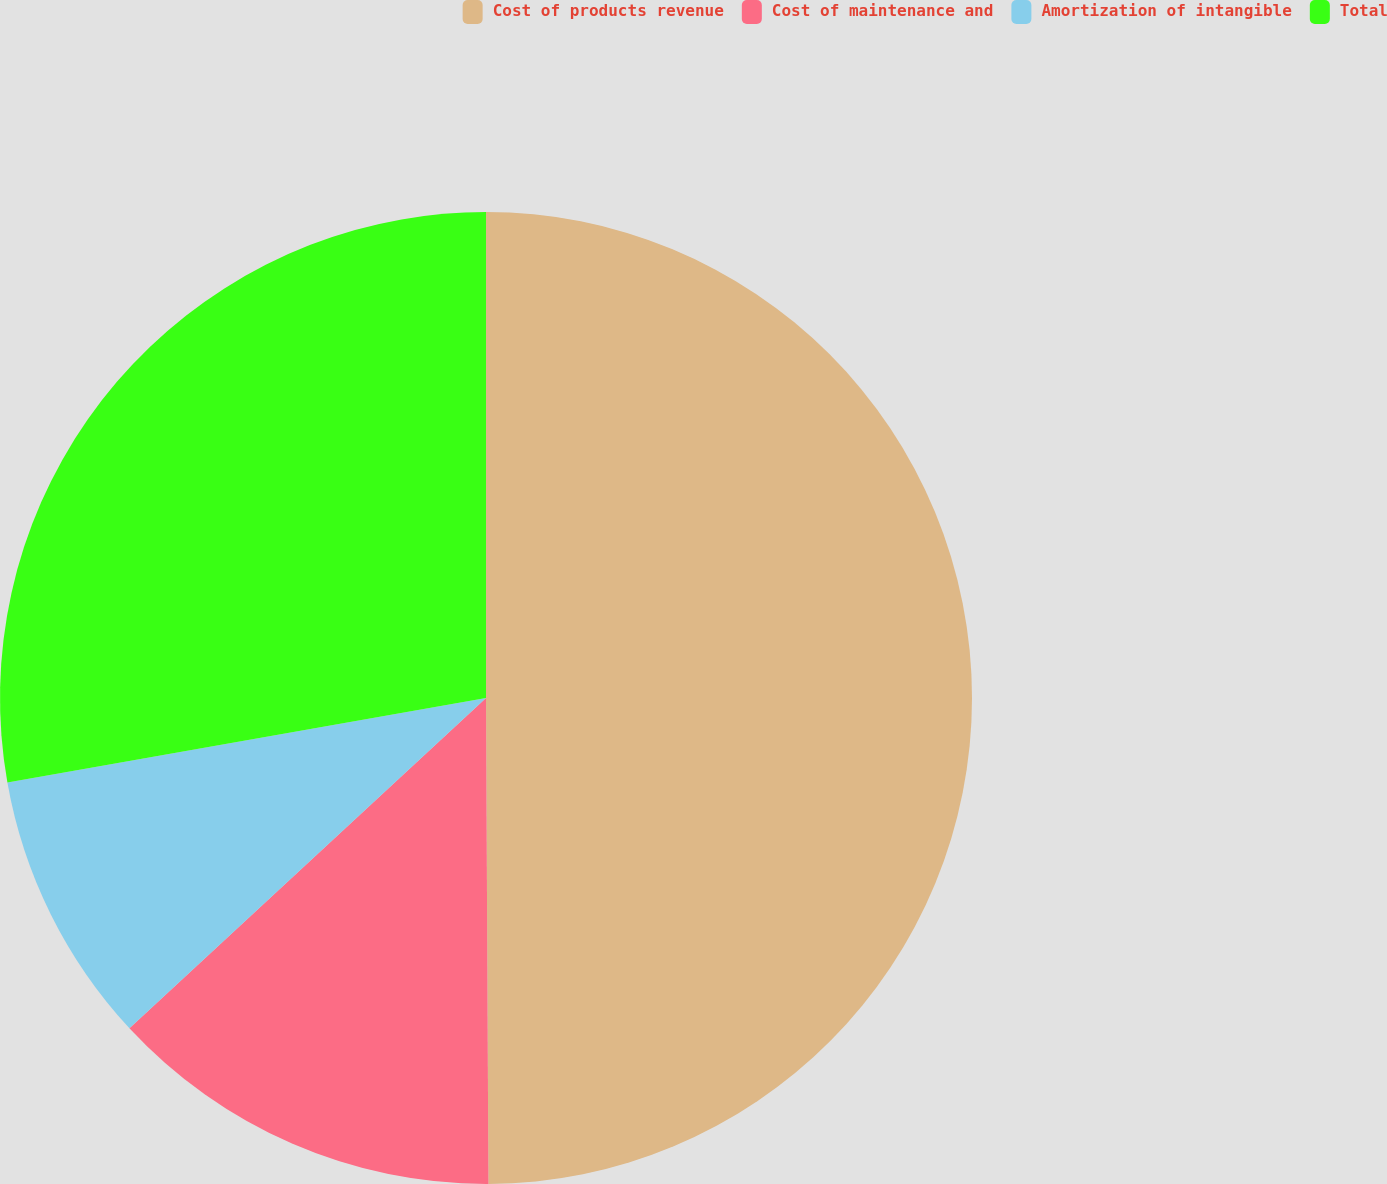<chart> <loc_0><loc_0><loc_500><loc_500><pie_chart><fcel>Cost of products revenue<fcel>Cost of maintenance and<fcel>Amortization of intangible<fcel>Total<nl><fcel>49.92%<fcel>13.19%<fcel>9.11%<fcel>27.78%<nl></chart> 